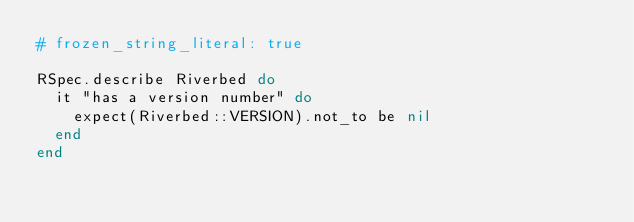Convert code to text. <code><loc_0><loc_0><loc_500><loc_500><_Ruby_># frozen_string_literal: true

RSpec.describe Riverbed do
  it "has a version number" do
    expect(Riverbed::VERSION).not_to be nil
  end
end
</code> 